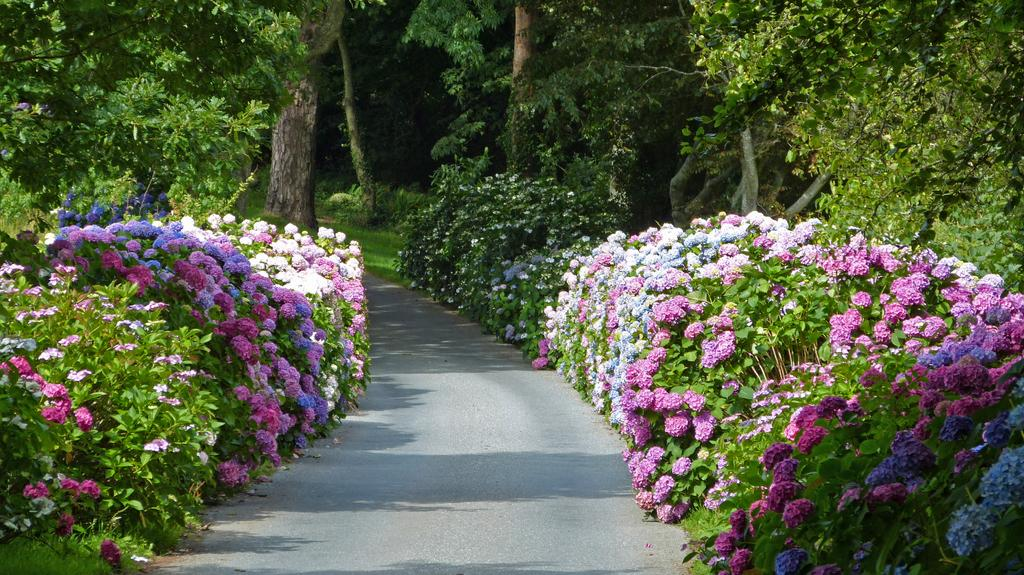What is the main feature of the image? There is a road in the image. What can be seen on both sides of the road? There are green trees and flowers on both sides of the road. Can you describe the flowers in more detail? The flowers are white, pink, and purple. How many pigs are running across the road in the image? There are no pigs present in the image; it only features a road, green trees, and flowers. 